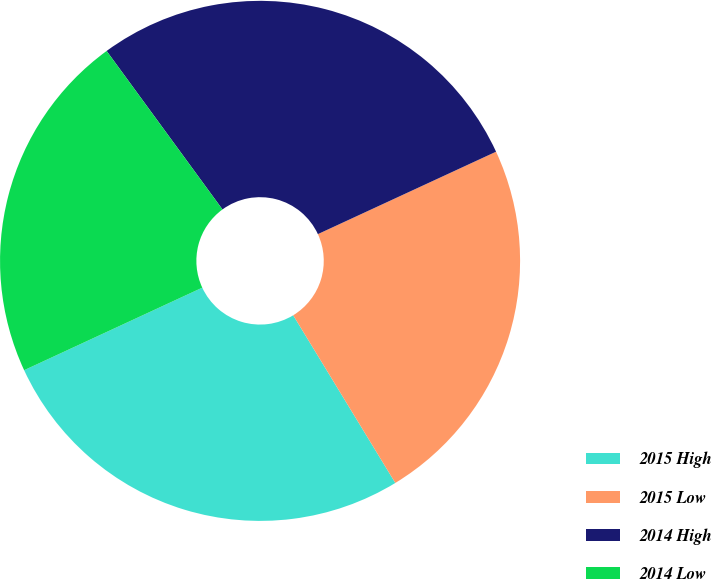Convert chart. <chart><loc_0><loc_0><loc_500><loc_500><pie_chart><fcel>2015 High<fcel>2015 Low<fcel>2014 High<fcel>2014 Low<nl><fcel>26.8%<fcel>23.19%<fcel>28.15%<fcel>21.86%<nl></chart> 